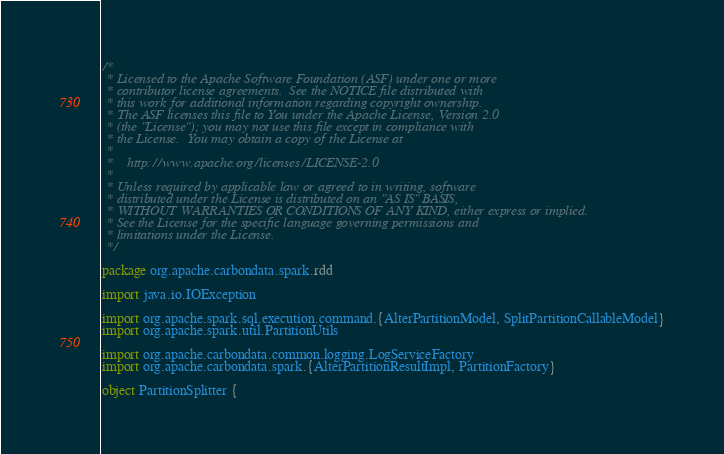Convert code to text. <code><loc_0><loc_0><loc_500><loc_500><_Scala_>/*
 * Licensed to the Apache Software Foundation (ASF) under one or more
 * contributor license agreements.  See the NOTICE file distributed with
 * this work for additional information regarding copyright ownership.
 * The ASF licenses this file to You under the Apache License, Version 2.0
 * (the "License"); you may not use this file except in compliance with
 * the License.  You may obtain a copy of the License at
 *
 *    http://www.apache.org/licenses/LICENSE-2.0
 *
 * Unless required by applicable law or agreed to in writing, software
 * distributed under the License is distributed on an "AS IS" BASIS,
 * WITHOUT WARRANTIES OR CONDITIONS OF ANY KIND, either express or implied.
 * See the License for the specific language governing permissions and
 * limitations under the License.
 */

package org.apache.carbondata.spark.rdd

import java.io.IOException

import org.apache.spark.sql.execution.command.{AlterPartitionModel, SplitPartitionCallableModel}
import org.apache.spark.util.PartitionUtils

import org.apache.carbondata.common.logging.LogServiceFactory
import org.apache.carbondata.spark.{AlterPartitionResultImpl, PartitionFactory}

object PartitionSplitter {
</code> 